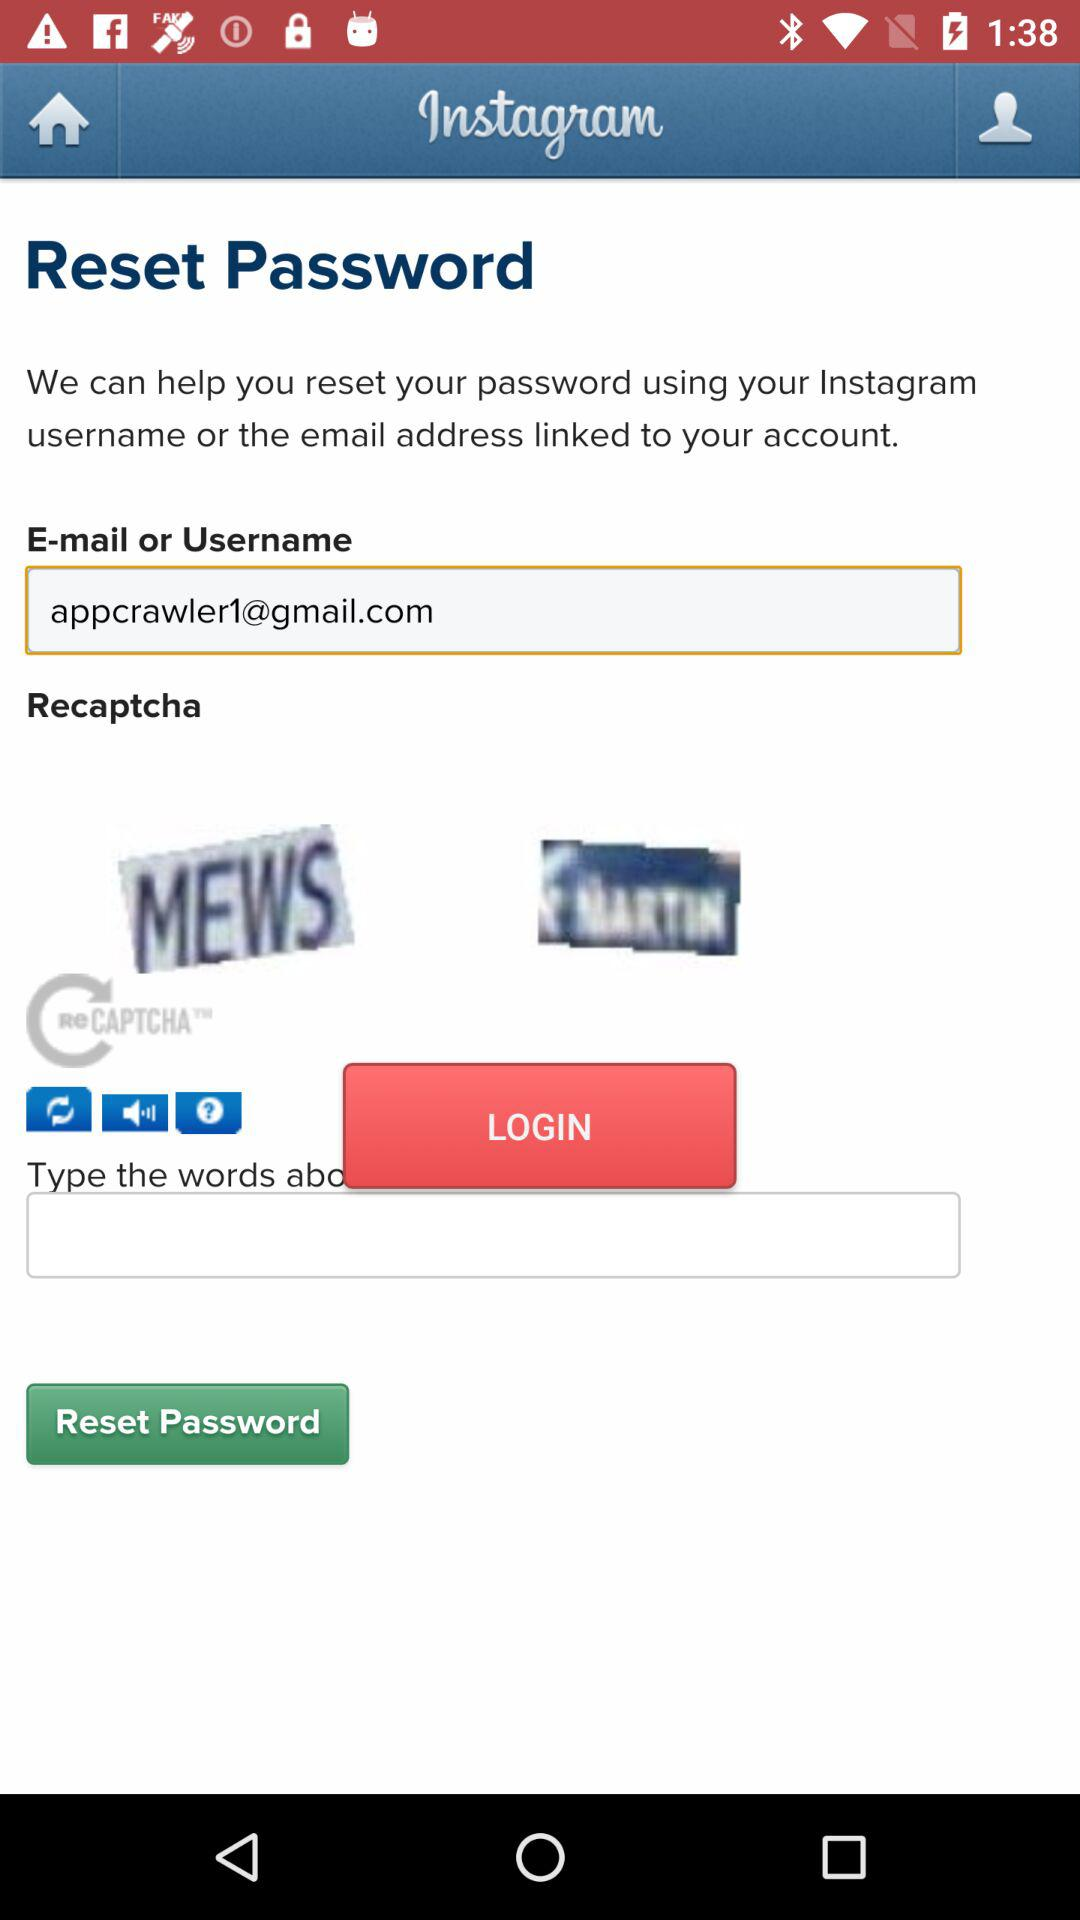What is the application name? The application name is "Instagram". 